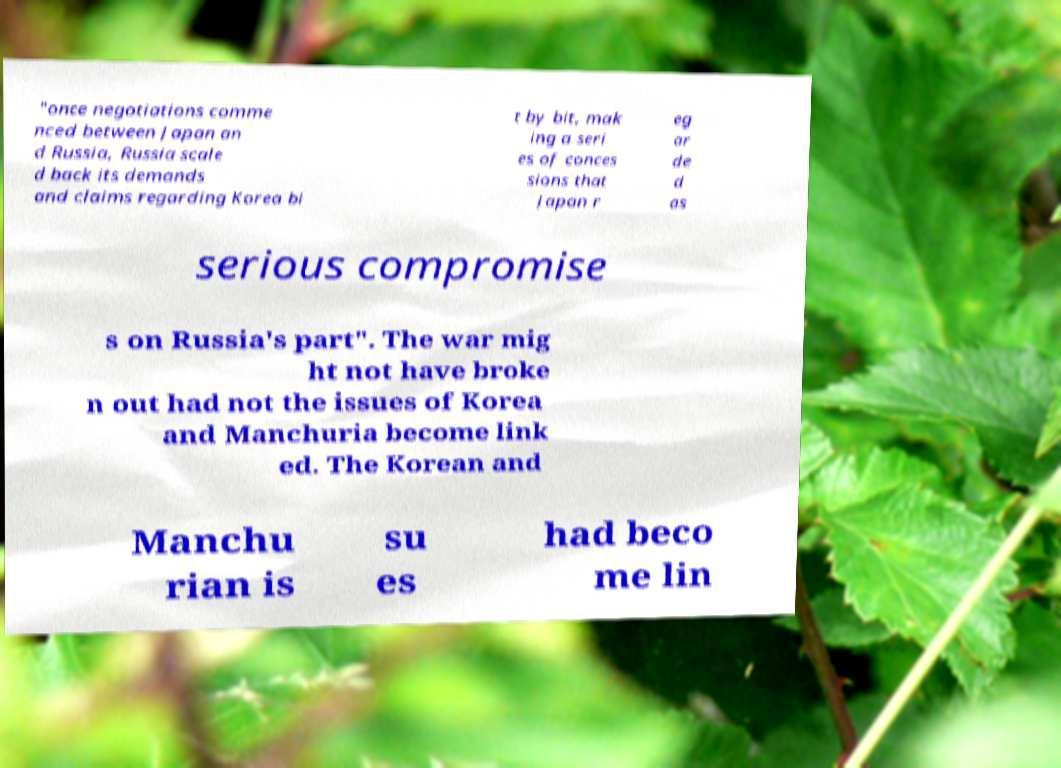There's text embedded in this image that I need extracted. Can you transcribe it verbatim? "once negotiations comme nced between Japan an d Russia, Russia scale d back its demands and claims regarding Korea bi t by bit, mak ing a seri es of conces sions that Japan r eg ar de d as serious compromise s on Russia's part". The war mig ht not have broke n out had not the issues of Korea and Manchuria become link ed. The Korean and Manchu rian is su es had beco me lin 